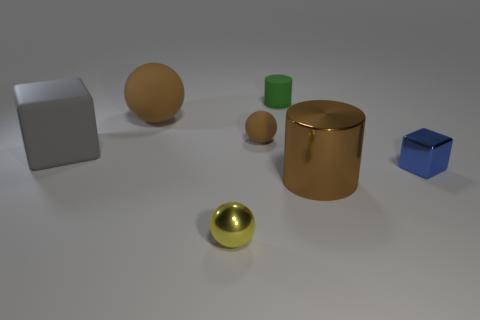There is a matte object that is the same color as the small rubber sphere; what size is it?
Your response must be concise. Large. What material is the other sphere that is the same color as the large matte ball?
Make the answer very short. Rubber. There is a big object that is both to the left of the brown cylinder and on the right side of the gray rubber cube; what material is it made of?
Give a very brief answer. Rubber. Are there an equal number of small green matte cylinders that are to the right of the blue block and big brown metallic objects?
Give a very brief answer. No. How many small brown matte things are the same shape as the tiny yellow thing?
Your answer should be very brief. 1. What is the size of the brown object that is in front of the large matte object that is in front of the big brown thing on the left side of the small brown thing?
Offer a terse response. Large. Do the small ball that is behind the gray object and the yellow thing have the same material?
Your response must be concise. No. Are there the same number of rubber spheres that are on the right side of the tiny blue thing and small blue objects behind the big brown sphere?
Make the answer very short. Yes. Is there anything else that is the same size as the gray cube?
Make the answer very short. Yes. What is the material of the yellow thing that is the same shape as the tiny brown thing?
Provide a succinct answer. Metal. 